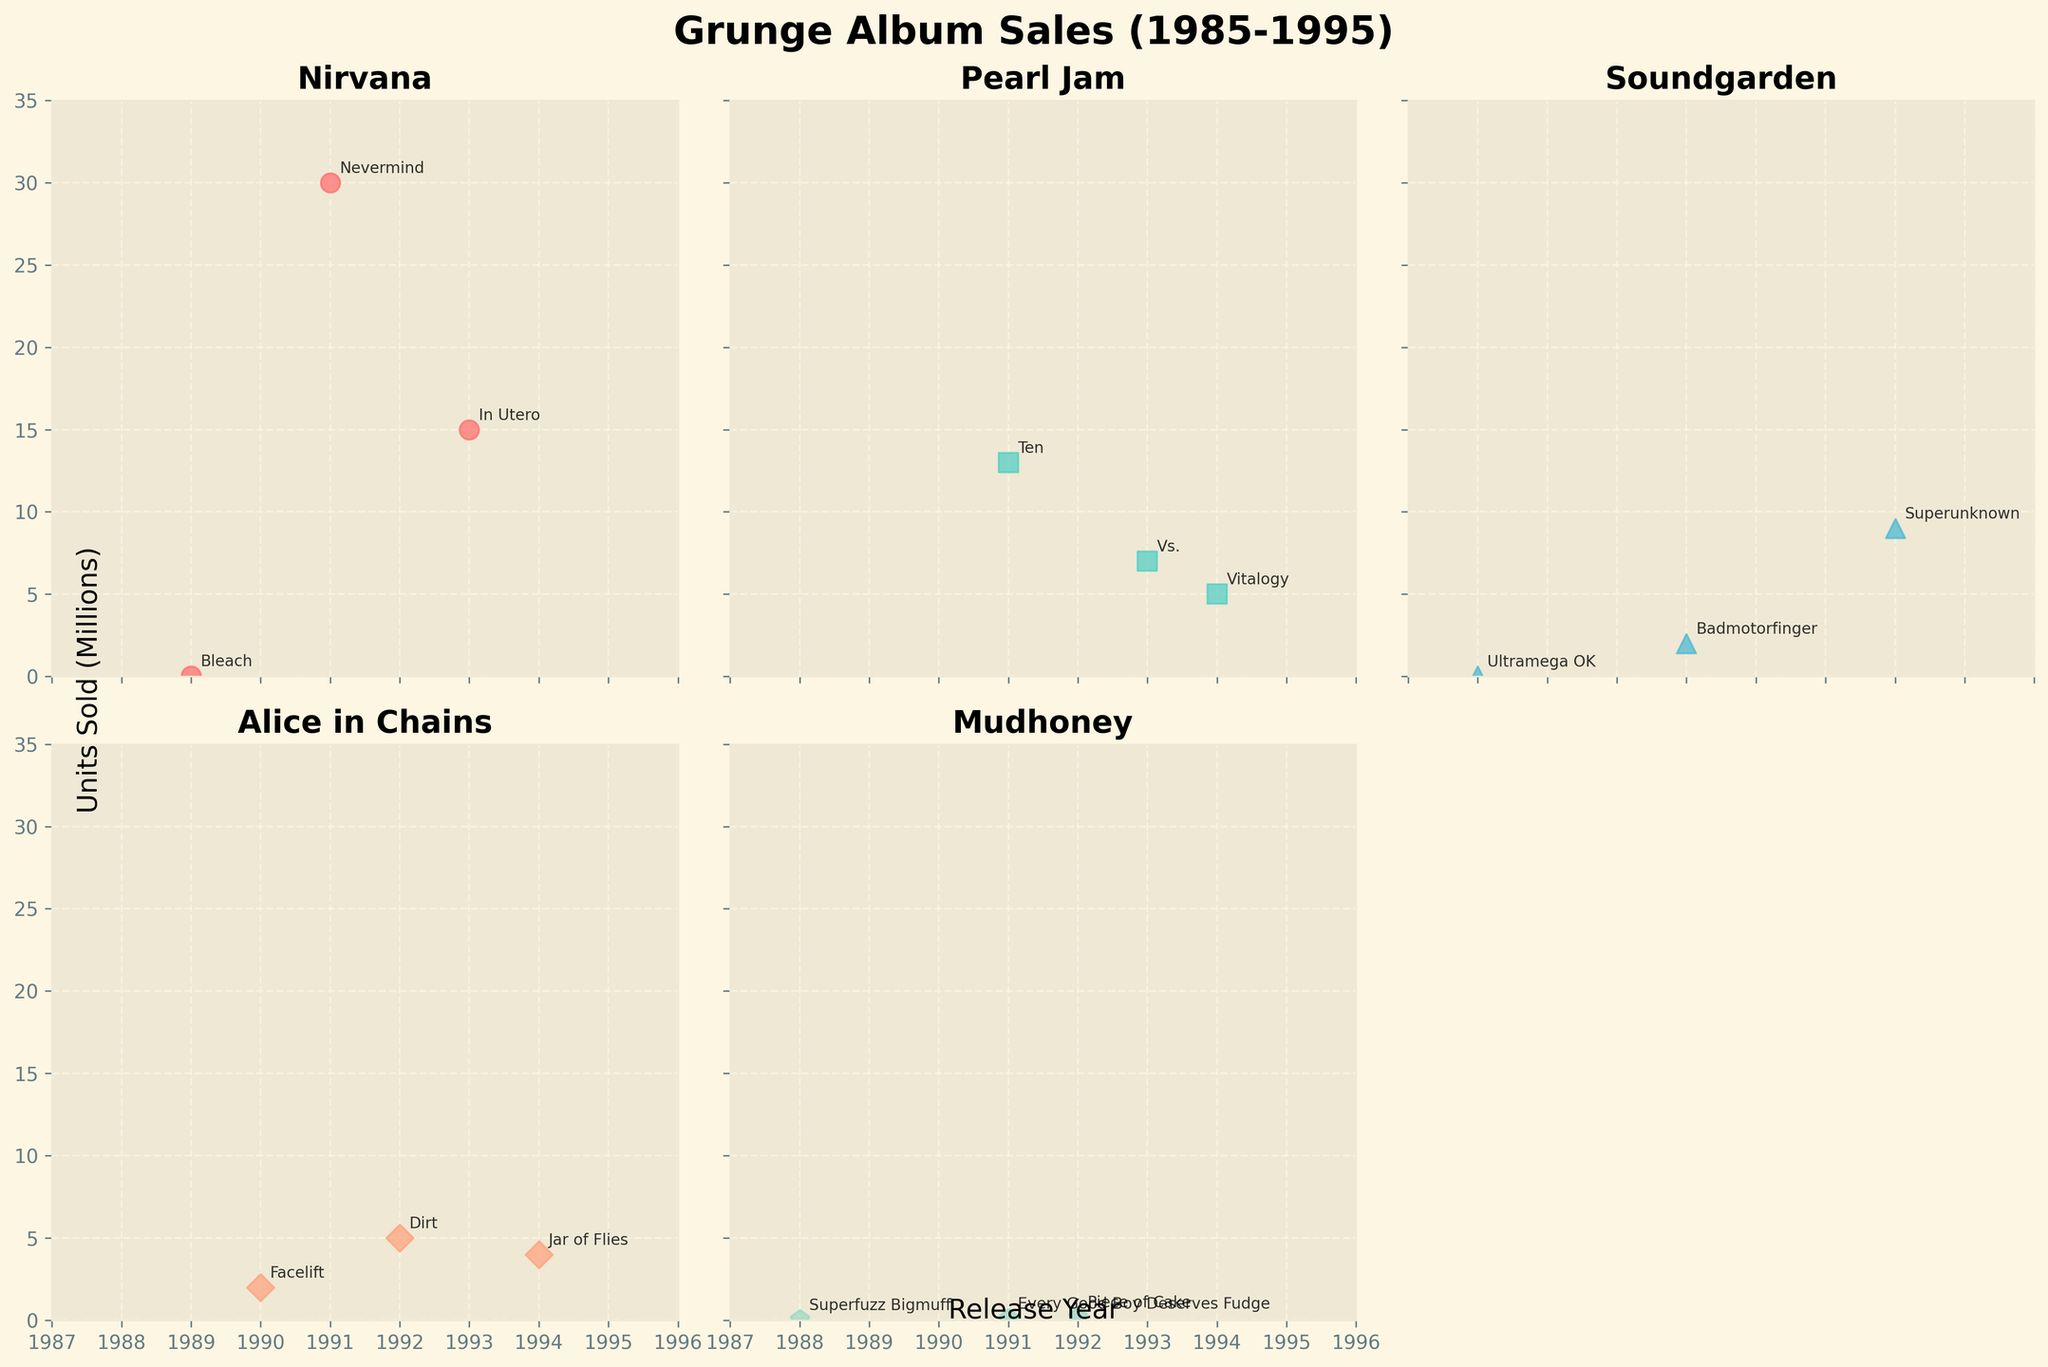What is the title of the figure? The title is usually displayed prominently at the top of the figure. The plot has a title centered above it that reads 'Grunge Album Sales (1985-1995)'.
Answer: Grunge Album Sales (1985-1995) Which band had the highest-selling album, and how many units did it sell? We look for the data point that is highest on the y-axis across all subplots. Nirvana's album 'Nevermind,' released in 1991, is the highest, with around 30 million units sold.
Answer: Nirvana, 30 million Which Pearl Jam album sold the least copy? By examining Pearl Jam's subplot, we identify the lowest point on the y-axis. The album 'Vitalogy,' released in 1994, sold 5 million units.
Answer: Vitalogy, 5 million How many albums did Nirvana release between 1989 and 1993? We count the data points in Nirvana's subplot that fall within the year range from 1989 to 1993. There are three albums: 'Bleach,' 'Nevermind,' and 'In Utero'.
Answer: 3 Compare the sales of Soundgarden's 'Badmotorfinger' and Alice in Chains' 'Dirt'. Which album sold more? We locate the data points for 'Badmotorfinger' in Soundgarden's subplot and 'Dirt' in Alice in Chains' subplot. 'Dirt' sold 5 million units while 'Badmotorfinger' sold 2 million units.
Answer: Dirt sold more What is the average number of units sold for Mudhoney's albums? We find Mudhoney's albums' sales: 'Superfuzz Bigmuff' (0.04 million), 'Every Good Boy Deserves Fudge' (0.1 million), and 'Piece of Cake' (0.2 million). Summing these gives 0.34 million, and dividing by 3 gives approximately 0.113 million.
Answer: 0.113 million Which band had the most albums released between 1985 and 1995? Count the data points representing albums for each band in their respective subplots. Pearl Jam has three albums: 'Ten,' 'Vs.,' and 'Vitalogy.' Nirvana also has three, as do Alice in Chains and Mudhoney. Soundgarden has three as well. Since all bands have released three albums, no band has the most.
Answer: All bands released 3 albums Among Nirvana, Pearl Jam, and Soundgarden, whose albums sold the most units in 1991? Checking 1991 for each band: Nirvana's 'Nevermind' sold 30 million units, Pearl Jam's 'Ten' sold 13 million units, and Soundgarden's 'Badmotorfinger' sold 2 million units.
Answer: Nirvana What was the difference in units sold between Nirvana's 'Bleach' and 'In Utero'? From Nirvana's subplot, 'Bleach' sold 0.03 million units and 'In Utero' sold 15 million units. The difference is 15 million - 0.03 million = 14.97 million units.
Answer: 14.97 million Which year had the highest number of albums released among all bands? Count the data points for each year across all subplots. The year 1991 has the highest number of albums released with Nirvana's 'Nevermind,' Pearl Jam's 'Ten,' Soundgarden's 'Badmotorfinger,' and Mudhoney's 'Every Good Boy Deserves Fudge.'
Answer: 1991 